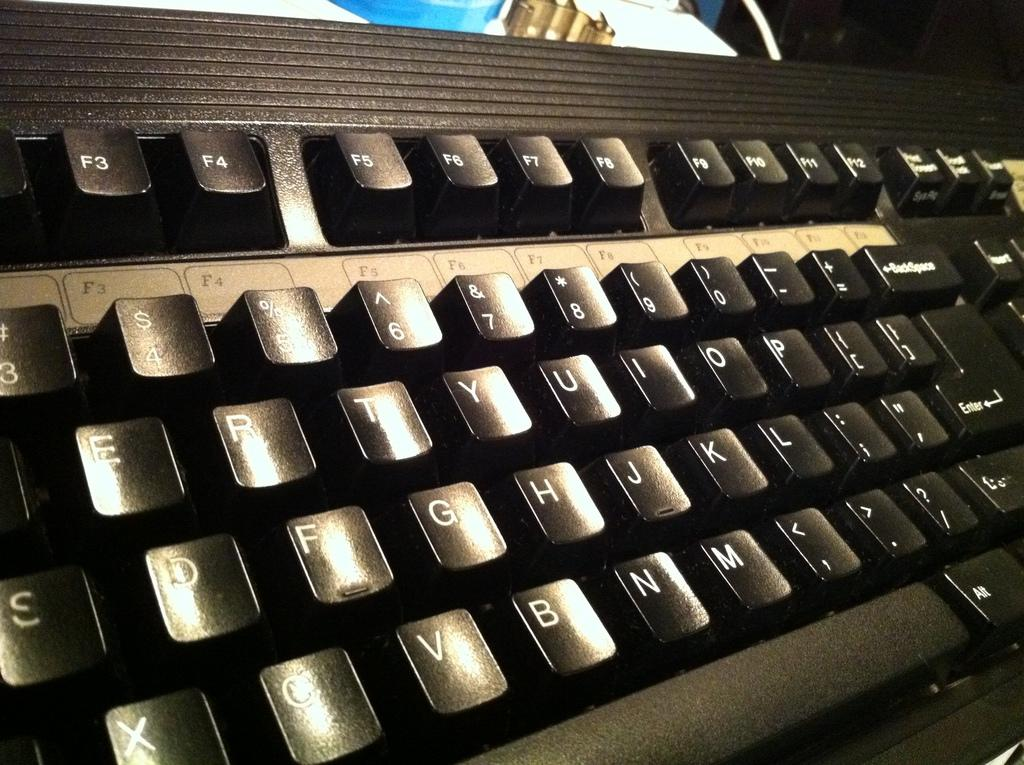Provide a one-sentence caption for the provided image. A QWERTY style keyboard with the Function keys has a slight glare on it. 